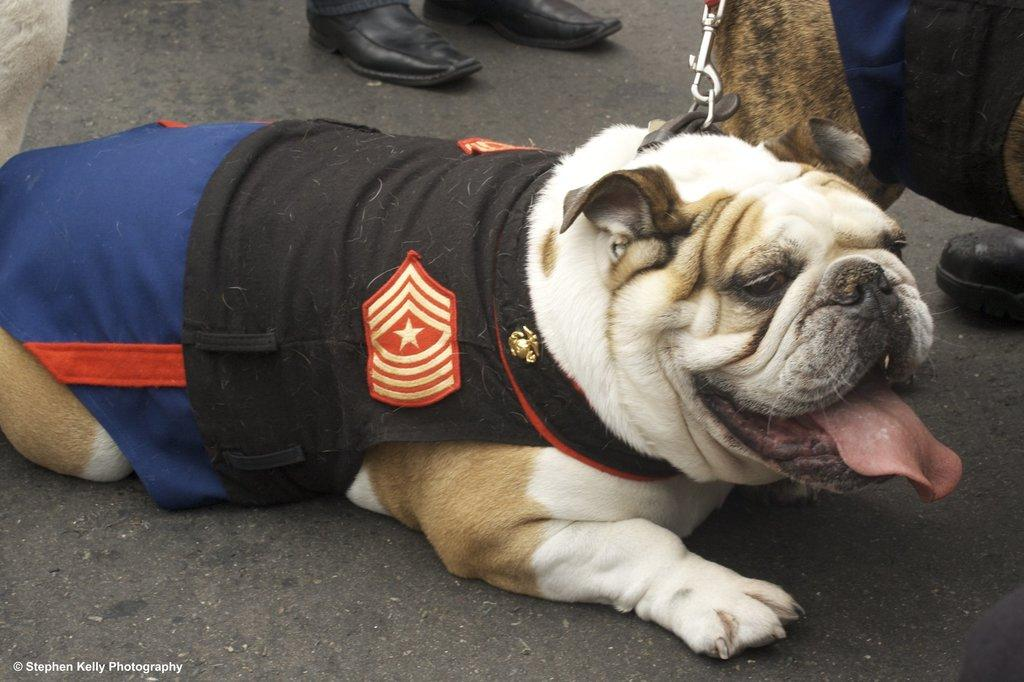What is the main subject in the foreground of the image? There is a dog in the foreground of the image. What is the dog standing on? The dog is on a black surface. Does the dog have any accessories? Yes, the dog has a belt. Can you see any part of a person in the image? Yes, there are legs of a person visible at the top of the image. What type of alarm can be heard going off in the image? There is no alarm present or audible in the image. Is the dog in a cave in the image? There is no indication of a cave in the image; the dog is on a black surface. 